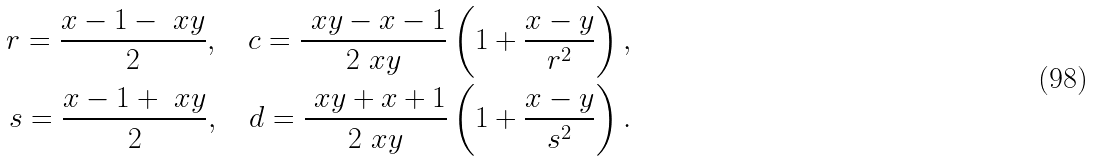<formula> <loc_0><loc_0><loc_500><loc_500>r = \frac { x - 1 - \ x y } { 2 } , \quad c = \frac { \ x y - x - 1 } { 2 \ x y } \left ( 1 + \frac { x - y } { r ^ { 2 } } \right ) , \\ s = \frac { x - 1 + \ x y } { 2 } , \quad d = \frac { \ x y + x + 1 } { 2 \ x y } \left ( 1 + \frac { x - y } { s ^ { 2 } } \right ) .</formula> 